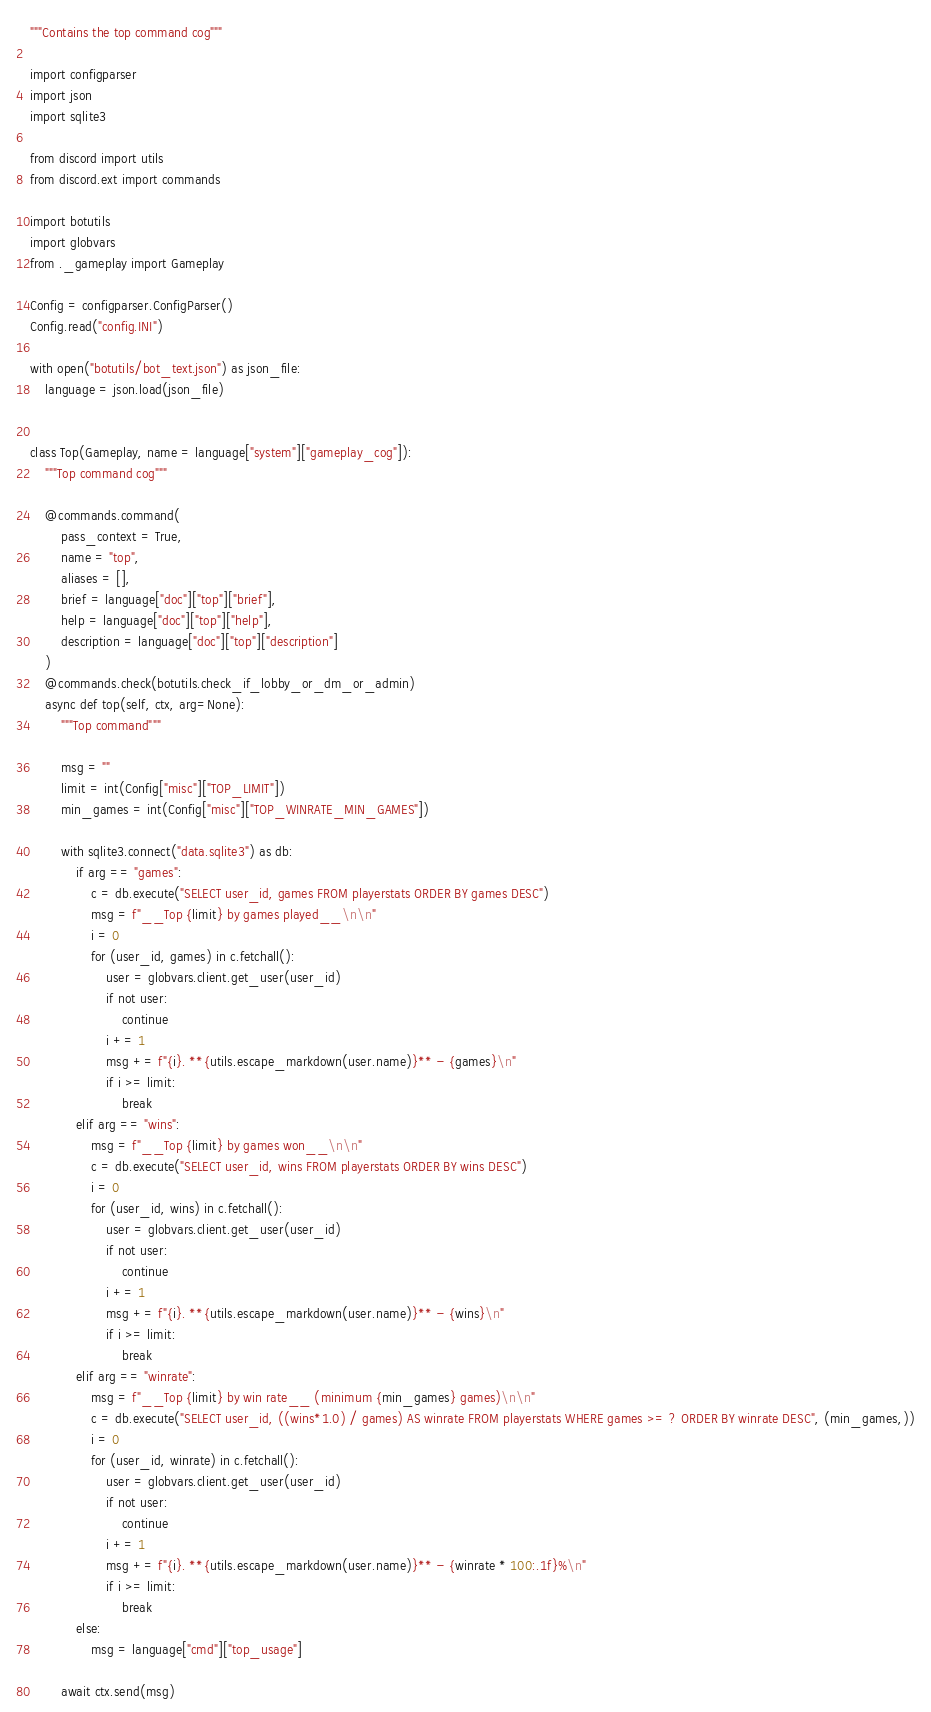Convert code to text. <code><loc_0><loc_0><loc_500><loc_500><_Python_>"""Contains the top command cog"""

import configparser
import json
import sqlite3

from discord import utils
from discord.ext import commands

import botutils
import globvars
from ._gameplay import Gameplay

Config = configparser.ConfigParser()
Config.read("config.INI")

with open("botutils/bot_text.json") as json_file:
    language = json.load(json_file)


class Top(Gameplay, name = language["system"]["gameplay_cog"]):
    """Top command cog"""

    @commands.command(
        pass_context = True,
        name = "top",
        aliases = [],
        brief = language["doc"]["top"]["brief"],
        help = language["doc"]["top"]["help"],
        description = language["doc"]["top"]["description"]
    )
    @commands.check(botutils.check_if_lobby_or_dm_or_admin)
    async def top(self, ctx, arg=None):
        """Top command"""

        msg = ""
        limit = int(Config["misc"]["TOP_LIMIT"])
        min_games = int(Config["misc"]["TOP_WINRATE_MIN_GAMES"])

        with sqlite3.connect("data.sqlite3") as db:
            if arg == "games":
                c = db.execute("SELECT user_id, games FROM playerstats ORDER BY games DESC")
                msg = f"__Top {limit} by games played__\n\n"
                i = 0
                for (user_id, games) in c.fetchall():
                    user = globvars.client.get_user(user_id)
                    if not user:
                        continue
                    i += 1
                    msg += f"{i}. **{utils.escape_markdown(user.name)}** - {games}\n"
                    if i >= limit:
                        break
            elif arg == "wins":
                msg = f"__Top {limit} by games won__\n\n"
                c = db.execute("SELECT user_id, wins FROM playerstats ORDER BY wins DESC")
                i = 0
                for (user_id, wins) in c.fetchall():
                    user = globvars.client.get_user(user_id)
                    if not user:
                        continue
                    i += 1
                    msg += f"{i}. **{utils.escape_markdown(user.name)}** - {wins}\n"
                    if i >= limit:
                        break
            elif arg == "winrate":
                msg = f"__Top {limit} by win rate__ (minimum {min_games} games)\n\n"
                c = db.execute("SELECT user_id, ((wins*1.0) / games) AS winrate FROM playerstats WHERE games >= ? ORDER BY winrate DESC", (min_games,))
                i = 0
                for (user_id, winrate) in c.fetchall():
                    user = globvars.client.get_user(user_id)
                    if not user:
                        continue
                    i += 1
                    msg += f"{i}. **{utils.escape_markdown(user.name)}** - {winrate * 100:.1f}%\n"
                    if i >= limit:
                        break
            else:
                msg = language["cmd"]["top_usage"]

        await ctx.send(msg)
</code> 